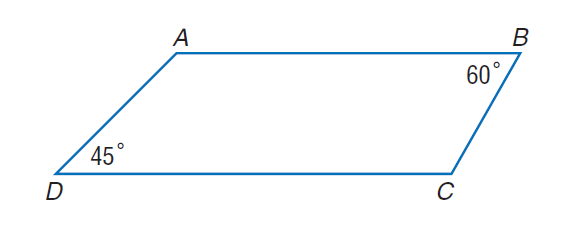Answer the mathemtical geometry problem and directly provide the correct option letter.
Question: Given figure A B C D, with A B \parallel D C, m \angle B = 60, m \angle D = 45, B C = 8 and A B = 24, find the perimeter.
Choices: A: 26 + 2 \sqrt { 3 } + 2 \sqrt { 6 } B: 26 + 4 \sqrt { 3 } + 4 \sqrt { 6 } C: 52 + 2 \sqrt { 3 } + 2 \sqrt { 6 } D: 52 + 4 \sqrt { 3 } + 4 \sqrt { 6 } D 